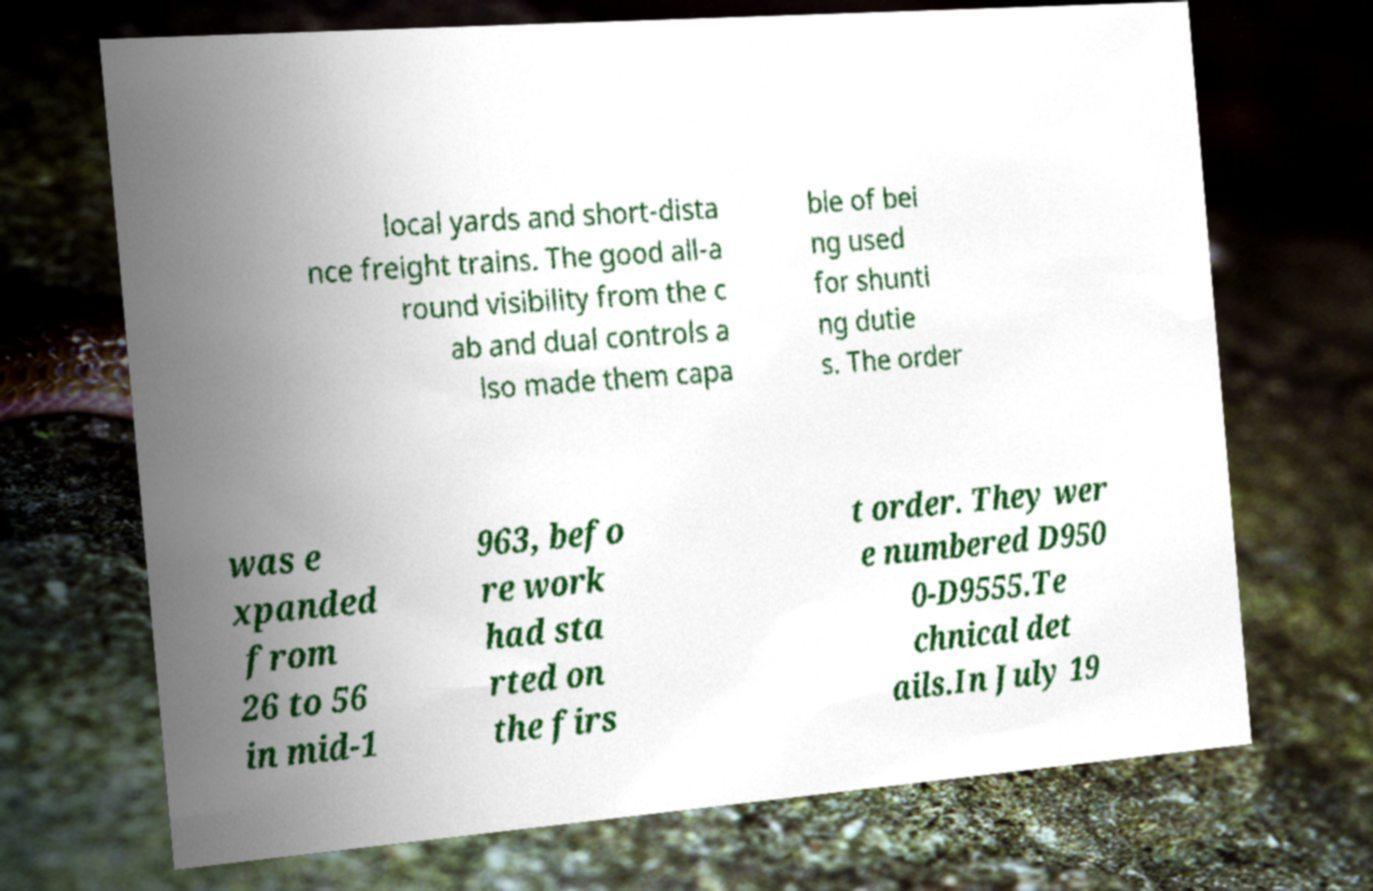Can you accurately transcribe the text from the provided image for me? local yards and short-dista nce freight trains. The good all-a round visibility from the c ab and dual controls a lso made them capa ble of bei ng used for shunti ng dutie s. The order was e xpanded from 26 to 56 in mid-1 963, befo re work had sta rted on the firs t order. They wer e numbered D950 0-D9555.Te chnical det ails.In July 19 